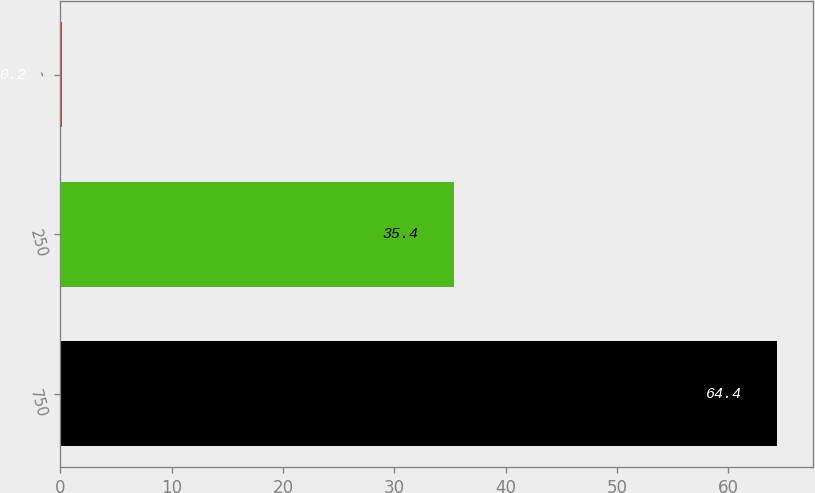Convert chart. <chart><loc_0><loc_0><loc_500><loc_500><bar_chart><fcel>750<fcel>250<fcel>-<nl><fcel>64.4<fcel>35.4<fcel>0.2<nl></chart> 